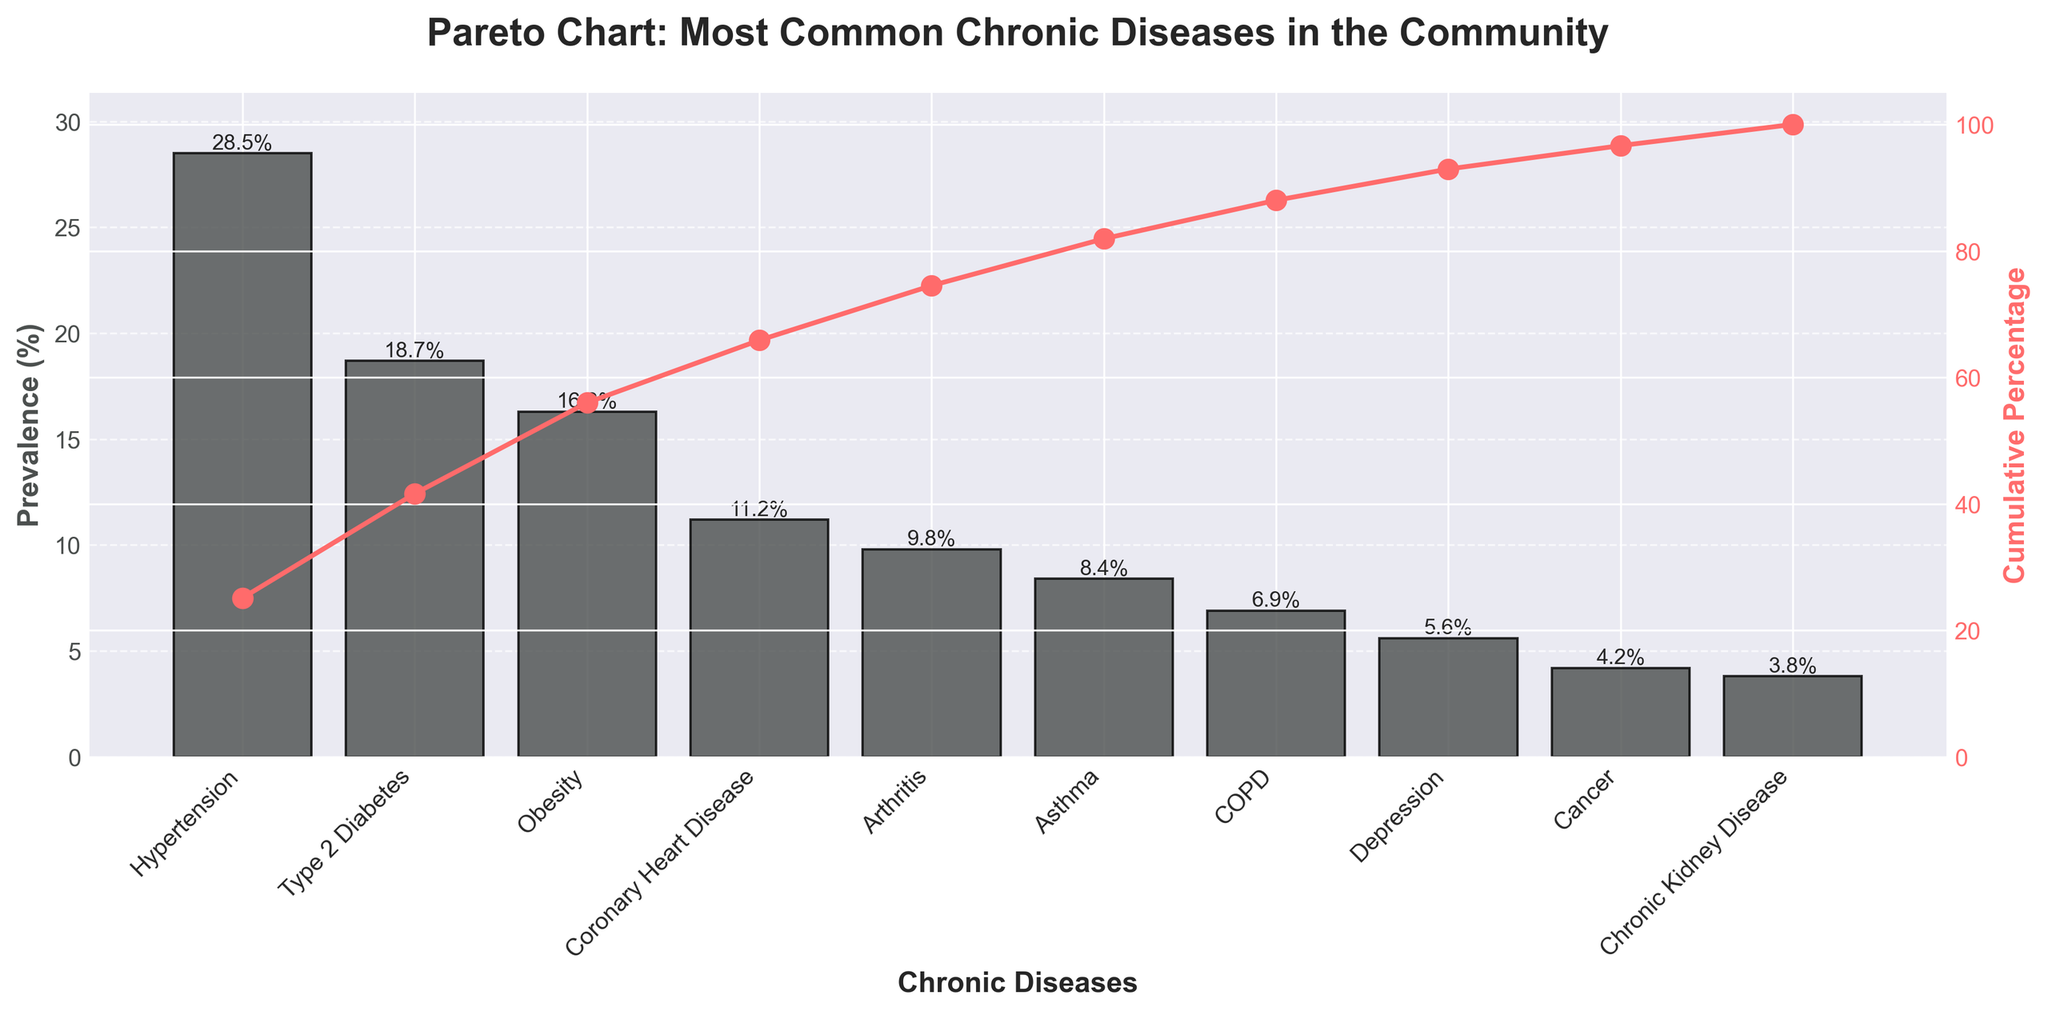What's the title of the chart? The title of the chart is displayed prominently at the top of the figure.
Answer: "Pareto Chart: Most Common Chronic Diseases in the Community" Which chronic disease has the highest prevalence? Look at the bars on the chart and identify which one is the tallest. The tallest bar represents the disease with the highest prevalence.
Answer: Hypertension What is the cumulative percentage after including Type 2 Diabetes? The cumulative percentage can be found in the line plot. Find the point corresponding to Type 2 Diabetes and read the y-axis value of the cumulative percentage.
Answer: 47.2% Arrange Obesity, Asthma, and Cancer in descending order of prevalence. Look at the heights of the bars that represent Obesity, Asthma, and Cancer. Compare their respective values and arrange them from highest to lowest.
Answer: Obesity, Asthma, Cancer What is the prevalence percentage of Asthma? Find the bar corresponding to Asthma and read its height, which represents the prevalence percentage.
Answer: 8.4% What's the total prevalence for the top three most common chronic diseases? Sum the prevalence percentages of Hypertension, Type 2 Diabetes, and Obesity. 28.5% + 18.7% + 16.3% = 63.5%
Answer: 63.5% How much more prevalent is Coronary Heart Disease compared to Chronic Kidney Disease? Subtract the prevalence percentage of Chronic Kidney Disease from that of Coronary Heart Disease. 11.2% - 3.8% = 7.4%
Answer: 7.4% At which chronic disease does the cumulative percentage cross 85%? Follow the cumulative percentage line and identify the chronic disease where the cumulative percentage first exceeds 85%.
Answer: COPD Compare the prevalence of Depression and Cancer. Which is higher? Look at the bars corresponding to Depression and Cancer and compare their heights.
Answer: Depression What's the combined prevalence of Arthritis and COPD? Add the prevalence percentages of Arthritis and COPD. 9.8% + 6.9% = 16.7%
Answer: 16.7% 